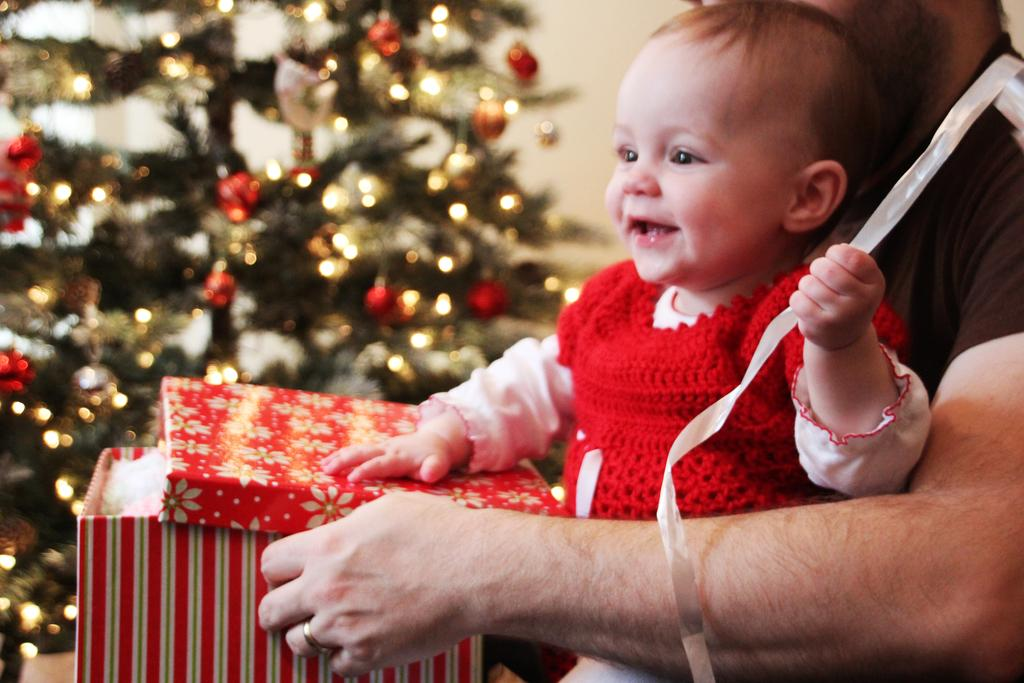Who is present on the right side of the image? There is a person on the right side of the image. What is the person holding? The person is holding a baby. What is the baby holding? The baby is holding gifts. What can be seen in the background of the image? There is a wall and a Christmas tree in the background of the image. What type of chain can be seen around the baby's neck in the image? There is no chain visible around the baby's neck in the image. 